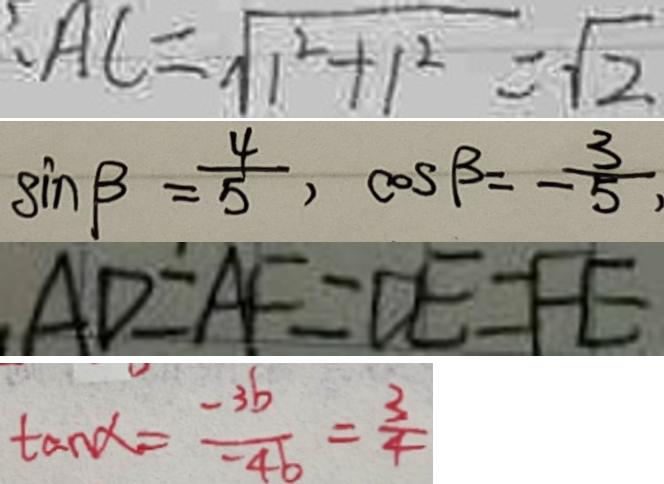<formula> <loc_0><loc_0><loc_500><loc_500>A C = \sqrt { 1 ^ { 2 } + 1 ^ { 2 } } = \sqrt { 2 } 
 \sin \beta = \frac { 4 } { 5 } , \cos \beta = - \frac { 3 } { 5 } , 
 A D = A F = D E = F E 
 \tan \alpha = \frac { - 3 b } { - 4 b } = \frac { 3 } { 4 }</formula> 